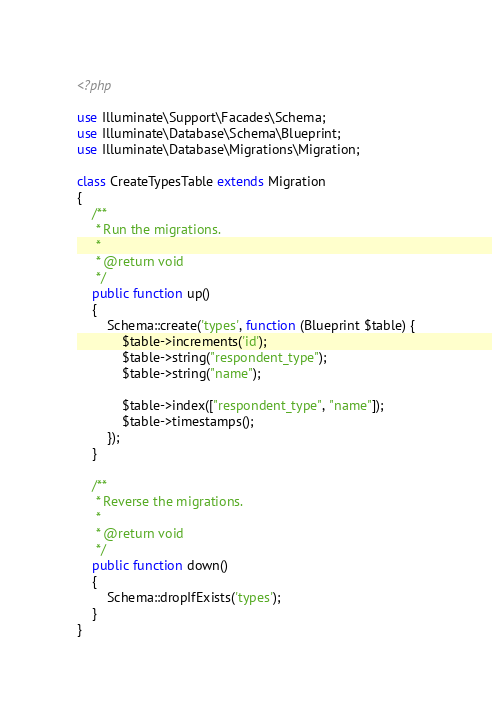<code> <loc_0><loc_0><loc_500><loc_500><_PHP_><?php

use Illuminate\Support\Facades\Schema;
use Illuminate\Database\Schema\Blueprint;
use Illuminate\Database\Migrations\Migration;

class CreateTypesTable extends Migration
{
    /**
     * Run the migrations.
     *
     * @return void
     */
    public function up()
    {
        Schema::create('types', function (Blueprint $table) {
            $table->increments('id');
            $table->string("respondent_type");
            $table->string("name");

            $table->index(["respondent_type", "name"]);
            $table->timestamps();
        });
    }

    /**
     * Reverse the migrations.
     *
     * @return void
     */
    public function down()
    {
        Schema::dropIfExists('types');
    }
}
</code> 